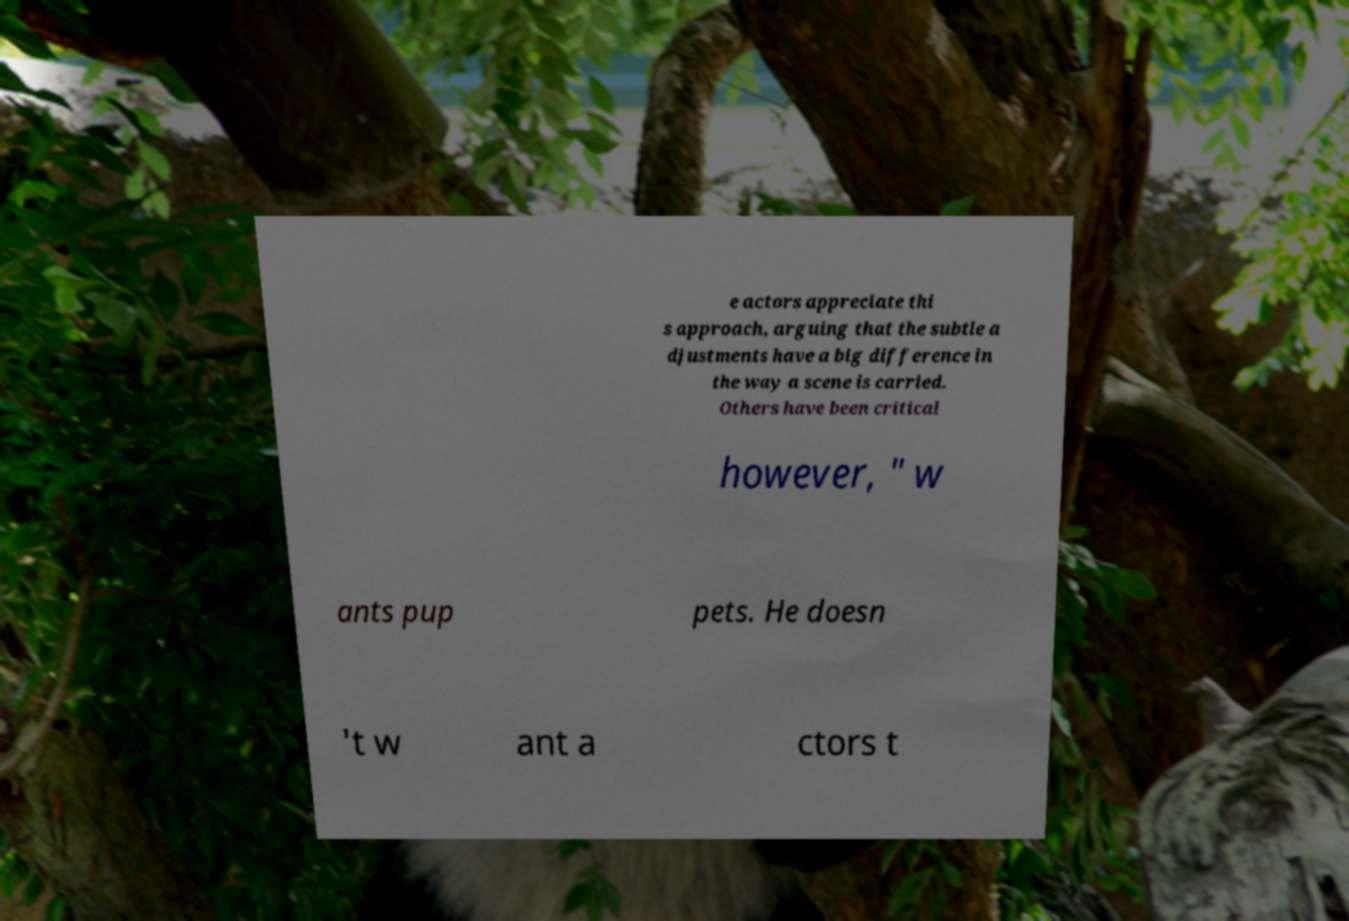There's text embedded in this image that I need extracted. Can you transcribe it verbatim? e actors appreciate thi s approach, arguing that the subtle a djustments have a big difference in the way a scene is carried. Others have been critical however, " w ants pup pets. He doesn 't w ant a ctors t 